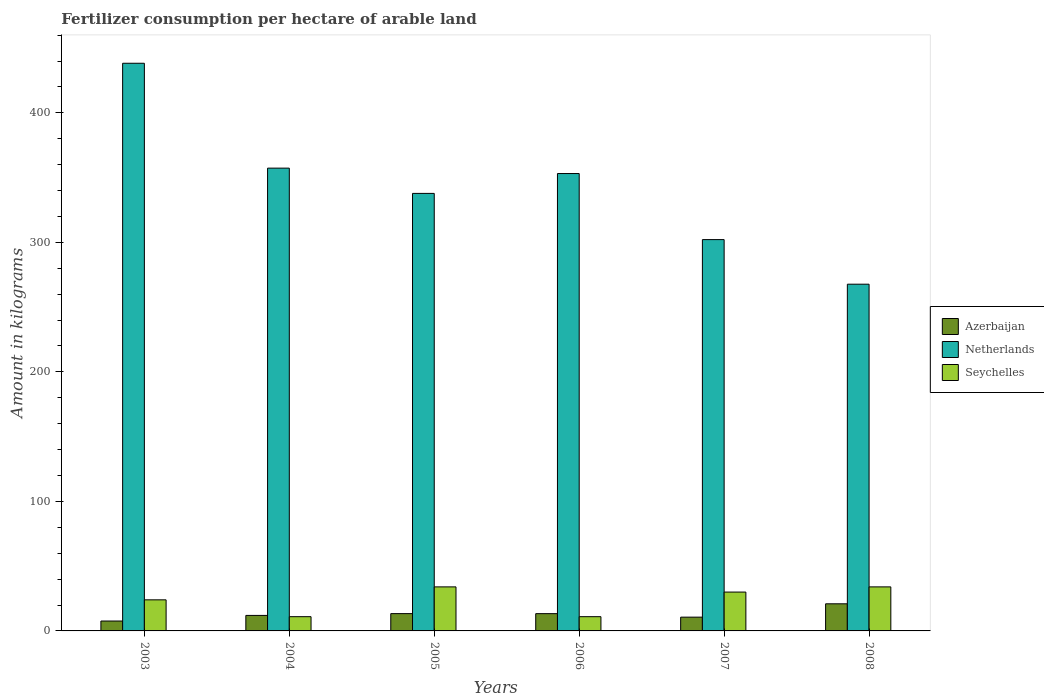How many groups of bars are there?
Offer a terse response. 6. Are the number of bars per tick equal to the number of legend labels?
Ensure brevity in your answer.  Yes. How many bars are there on the 3rd tick from the left?
Provide a succinct answer. 3. How many bars are there on the 1st tick from the right?
Give a very brief answer. 3. What is the label of the 5th group of bars from the left?
Give a very brief answer. 2007. In how many cases, is the number of bars for a given year not equal to the number of legend labels?
Offer a very short reply. 0. What is the amount of fertilizer consumption in Azerbaijan in 2007?
Make the answer very short. 10.64. Across all years, what is the maximum amount of fertilizer consumption in Azerbaijan?
Give a very brief answer. 20.94. Across all years, what is the minimum amount of fertilizer consumption in Seychelles?
Keep it short and to the point. 11. In which year was the amount of fertilizer consumption in Netherlands minimum?
Keep it short and to the point. 2008. What is the total amount of fertilizer consumption in Seychelles in the graph?
Keep it short and to the point. 144. What is the difference between the amount of fertilizer consumption in Netherlands in 2003 and that in 2006?
Your answer should be compact. 85.15. What is the difference between the amount of fertilizer consumption in Azerbaijan in 2003 and the amount of fertilizer consumption in Netherlands in 2005?
Keep it short and to the point. -330.16. In the year 2006, what is the difference between the amount of fertilizer consumption in Netherlands and amount of fertilizer consumption in Seychelles?
Provide a short and direct response. 342.15. What is the ratio of the amount of fertilizer consumption in Azerbaijan in 2005 to that in 2006?
Give a very brief answer. 1. Is the amount of fertilizer consumption in Seychelles in 2004 less than that in 2007?
Give a very brief answer. Yes. Is the difference between the amount of fertilizer consumption in Netherlands in 2003 and 2005 greater than the difference between the amount of fertilizer consumption in Seychelles in 2003 and 2005?
Your response must be concise. Yes. What is the difference between the highest and the second highest amount of fertilizer consumption in Seychelles?
Your response must be concise. 0. What is the difference between the highest and the lowest amount of fertilizer consumption in Seychelles?
Provide a short and direct response. 23. What does the 1st bar from the left in 2004 represents?
Keep it short and to the point. Azerbaijan. What does the 1st bar from the right in 2003 represents?
Make the answer very short. Seychelles. Is it the case that in every year, the sum of the amount of fertilizer consumption in Netherlands and amount of fertilizer consumption in Seychelles is greater than the amount of fertilizer consumption in Azerbaijan?
Keep it short and to the point. Yes. How many bars are there?
Make the answer very short. 18. What is the difference between two consecutive major ticks on the Y-axis?
Offer a very short reply. 100. Does the graph contain any zero values?
Offer a terse response. No. Does the graph contain grids?
Offer a very short reply. No. Where does the legend appear in the graph?
Make the answer very short. Center right. How many legend labels are there?
Make the answer very short. 3. How are the legend labels stacked?
Keep it short and to the point. Vertical. What is the title of the graph?
Offer a very short reply. Fertilizer consumption per hectare of arable land. What is the label or title of the Y-axis?
Offer a terse response. Amount in kilograms. What is the Amount in kilograms of Azerbaijan in 2003?
Give a very brief answer. 7.64. What is the Amount in kilograms of Netherlands in 2003?
Keep it short and to the point. 438.29. What is the Amount in kilograms in Seychelles in 2003?
Give a very brief answer. 24. What is the Amount in kilograms in Azerbaijan in 2004?
Give a very brief answer. 11.97. What is the Amount in kilograms of Netherlands in 2004?
Offer a terse response. 357.31. What is the Amount in kilograms in Azerbaijan in 2005?
Offer a terse response. 13.36. What is the Amount in kilograms in Netherlands in 2005?
Your answer should be compact. 337.81. What is the Amount in kilograms in Azerbaijan in 2006?
Give a very brief answer. 13.34. What is the Amount in kilograms in Netherlands in 2006?
Keep it short and to the point. 353.15. What is the Amount in kilograms of Azerbaijan in 2007?
Ensure brevity in your answer.  10.64. What is the Amount in kilograms in Netherlands in 2007?
Offer a very short reply. 302.14. What is the Amount in kilograms in Azerbaijan in 2008?
Provide a short and direct response. 20.94. What is the Amount in kilograms of Netherlands in 2008?
Your response must be concise. 267.71. Across all years, what is the maximum Amount in kilograms of Azerbaijan?
Make the answer very short. 20.94. Across all years, what is the maximum Amount in kilograms in Netherlands?
Your answer should be very brief. 438.29. Across all years, what is the maximum Amount in kilograms of Seychelles?
Make the answer very short. 34. Across all years, what is the minimum Amount in kilograms in Azerbaijan?
Provide a short and direct response. 7.64. Across all years, what is the minimum Amount in kilograms in Netherlands?
Provide a succinct answer. 267.71. What is the total Amount in kilograms of Azerbaijan in the graph?
Your answer should be very brief. 77.89. What is the total Amount in kilograms of Netherlands in the graph?
Your response must be concise. 2056.41. What is the total Amount in kilograms in Seychelles in the graph?
Your response must be concise. 144. What is the difference between the Amount in kilograms of Azerbaijan in 2003 and that in 2004?
Provide a short and direct response. -4.33. What is the difference between the Amount in kilograms of Netherlands in 2003 and that in 2004?
Offer a very short reply. 80.98. What is the difference between the Amount in kilograms of Azerbaijan in 2003 and that in 2005?
Provide a short and direct response. -5.72. What is the difference between the Amount in kilograms in Netherlands in 2003 and that in 2005?
Give a very brief answer. 100.48. What is the difference between the Amount in kilograms of Seychelles in 2003 and that in 2005?
Your response must be concise. -10. What is the difference between the Amount in kilograms of Azerbaijan in 2003 and that in 2006?
Provide a short and direct response. -5.7. What is the difference between the Amount in kilograms of Netherlands in 2003 and that in 2006?
Make the answer very short. 85.14. What is the difference between the Amount in kilograms of Seychelles in 2003 and that in 2006?
Your answer should be very brief. 13. What is the difference between the Amount in kilograms in Azerbaijan in 2003 and that in 2007?
Offer a terse response. -3. What is the difference between the Amount in kilograms of Netherlands in 2003 and that in 2007?
Keep it short and to the point. 136.15. What is the difference between the Amount in kilograms in Azerbaijan in 2003 and that in 2008?
Ensure brevity in your answer.  -13.3. What is the difference between the Amount in kilograms in Netherlands in 2003 and that in 2008?
Provide a succinct answer. 170.58. What is the difference between the Amount in kilograms of Azerbaijan in 2004 and that in 2005?
Ensure brevity in your answer.  -1.39. What is the difference between the Amount in kilograms in Netherlands in 2004 and that in 2005?
Your answer should be compact. 19.51. What is the difference between the Amount in kilograms of Seychelles in 2004 and that in 2005?
Offer a very short reply. -23. What is the difference between the Amount in kilograms in Azerbaijan in 2004 and that in 2006?
Offer a terse response. -1.36. What is the difference between the Amount in kilograms of Netherlands in 2004 and that in 2006?
Provide a short and direct response. 4.17. What is the difference between the Amount in kilograms of Seychelles in 2004 and that in 2006?
Your response must be concise. 0. What is the difference between the Amount in kilograms in Azerbaijan in 2004 and that in 2007?
Your answer should be compact. 1.34. What is the difference between the Amount in kilograms of Netherlands in 2004 and that in 2007?
Give a very brief answer. 55.17. What is the difference between the Amount in kilograms in Seychelles in 2004 and that in 2007?
Ensure brevity in your answer.  -19. What is the difference between the Amount in kilograms of Azerbaijan in 2004 and that in 2008?
Keep it short and to the point. -8.96. What is the difference between the Amount in kilograms of Netherlands in 2004 and that in 2008?
Your answer should be very brief. 89.6. What is the difference between the Amount in kilograms in Seychelles in 2004 and that in 2008?
Ensure brevity in your answer.  -23. What is the difference between the Amount in kilograms in Azerbaijan in 2005 and that in 2006?
Your answer should be very brief. 0.02. What is the difference between the Amount in kilograms in Netherlands in 2005 and that in 2006?
Your answer should be compact. -15.34. What is the difference between the Amount in kilograms of Seychelles in 2005 and that in 2006?
Provide a short and direct response. 23. What is the difference between the Amount in kilograms in Azerbaijan in 2005 and that in 2007?
Keep it short and to the point. 2.72. What is the difference between the Amount in kilograms of Netherlands in 2005 and that in 2007?
Your answer should be compact. 35.67. What is the difference between the Amount in kilograms of Azerbaijan in 2005 and that in 2008?
Your answer should be very brief. -7.58. What is the difference between the Amount in kilograms of Netherlands in 2005 and that in 2008?
Provide a succinct answer. 70.1. What is the difference between the Amount in kilograms in Azerbaijan in 2006 and that in 2007?
Provide a short and direct response. 2.7. What is the difference between the Amount in kilograms of Netherlands in 2006 and that in 2007?
Provide a short and direct response. 51.01. What is the difference between the Amount in kilograms of Azerbaijan in 2006 and that in 2008?
Your response must be concise. -7.6. What is the difference between the Amount in kilograms of Netherlands in 2006 and that in 2008?
Keep it short and to the point. 85.44. What is the difference between the Amount in kilograms of Seychelles in 2006 and that in 2008?
Make the answer very short. -23. What is the difference between the Amount in kilograms in Azerbaijan in 2007 and that in 2008?
Offer a terse response. -10.3. What is the difference between the Amount in kilograms of Netherlands in 2007 and that in 2008?
Offer a very short reply. 34.43. What is the difference between the Amount in kilograms in Azerbaijan in 2003 and the Amount in kilograms in Netherlands in 2004?
Your response must be concise. -349.67. What is the difference between the Amount in kilograms in Azerbaijan in 2003 and the Amount in kilograms in Seychelles in 2004?
Provide a short and direct response. -3.36. What is the difference between the Amount in kilograms in Netherlands in 2003 and the Amount in kilograms in Seychelles in 2004?
Your answer should be very brief. 427.29. What is the difference between the Amount in kilograms of Azerbaijan in 2003 and the Amount in kilograms of Netherlands in 2005?
Your answer should be very brief. -330.16. What is the difference between the Amount in kilograms in Azerbaijan in 2003 and the Amount in kilograms in Seychelles in 2005?
Your response must be concise. -26.36. What is the difference between the Amount in kilograms in Netherlands in 2003 and the Amount in kilograms in Seychelles in 2005?
Keep it short and to the point. 404.29. What is the difference between the Amount in kilograms in Azerbaijan in 2003 and the Amount in kilograms in Netherlands in 2006?
Keep it short and to the point. -345.5. What is the difference between the Amount in kilograms in Azerbaijan in 2003 and the Amount in kilograms in Seychelles in 2006?
Offer a very short reply. -3.36. What is the difference between the Amount in kilograms in Netherlands in 2003 and the Amount in kilograms in Seychelles in 2006?
Ensure brevity in your answer.  427.29. What is the difference between the Amount in kilograms of Azerbaijan in 2003 and the Amount in kilograms of Netherlands in 2007?
Ensure brevity in your answer.  -294.5. What is the difference between the Amount in kilograms of Azerbaijan in 2003 and the Amount in kilograms of Seychelles in 2007?
Your response must be concise. -22.36. What is the difference between the Amount in kilograms in Netherlands in 2003 and the Amount in kilograms in Seychelles in 2007?
Give a very brief answer. 408.29. What is the difference between the Amount in kilograms of Azerbaijan in 2003 and the Amount in kilograms of Netherlands in 2008?
Offer a terse response. -260.07. What is the difference between the Amount in kilograms of Azerbaijan in 2003 and the Amount in kilograms of Seychelles in 2008?
Make the answer very short. -26.36. What is the difference between the Amount in kilograms in Netherlands in 2003 and the Amount in kilograms in Seychelles in 2008?
Provide a short and direct response. 404.29. What is the difference between the Amount in kilograms in Azerbaijan in 2004 and the Amount in kilograms in Netherlands in 2005?
Keep it short and to the point. -325.83. What is the difference between the Amount in kilograms in Azerbaijan in 2004 and the Amount in kilograms in Seychelles in 2005?
Ensure brevity in your answer.  -22.03. What is the difference between the Amount in kilograms of Netherlands in 2004 and the Amount in kilograms of Seychelles in 2005?
Your answer should be very brief. 323.31. What is the difference between the Amount in kilograms of Azerbaijan in 2004 and the Amount in kilograms of Netherlands in 2006?
Provide a succinct answer. -341.17. What is the difference between the Amount in kilograms in Azerbaijan in 2004 and the Amount in kilograms in Seychelles in 2006?
Ensure brevity in your answer.  0.97. What is the difference between the Amount in kilograms of Netherlands in 2004 and the Amount in kilograms of Seychelles in 2006?
Your answer should be very brief. 346.31. What is the difference between the Amount in kilograms in Azerbaijan in 2004 and the Amount in kilograms in Netherlands in 2007?
Offer a very short reply. -290.16. What is the difference between the Amount in kilograms in Azerbaijan in 2004 and the Amount in kilograms in Seychelles in 2007?
Keep it short and to the point. -18.03. What is the difference between the Amount in kilograms of Netherlands in 2004 and the Amount in kilograms of Seychelles in 2007?
Give a very brief answer. 327.31. What is the difference between the Amount in kilograms of Azerbaijan in 2004 and the Amount in kilograms of Netherlands in 2008?
Keep it short and to the point. -255.73. What is the difference between the Amount in kilograms of Azerbaijan in 2004 and the Amount in kilograms of Seychelles in 2008?
Your answer should be very brief. -22.03. What is the difference between the Amount in kilograms in Netherlands in 2004 and the Amount in kilograms in Seychelles in 2008?
Provide a succinct answer. 323.31. What is the difference between the Amount in kilograms of Azerbaijan in 2005 and the Amount in kilograms of Netherlands in 2006?
Keep it short and to the point. -339.79. What is the difference between the Amount in kilograms in Azerbaijan in 2005 and the Amount in kilograms in Seychelles in 2006?
Provide a succinct answer. 2.36. What is the difference between the Amount in kilograms in Netherlands in 2005 and the Amount in kilograms in Seychelles in 2006?
Offer a very short reply. 326.81. What is the difference between the Amount in kilograms in Azerbaijan in 2005 and the Amount in kilograms in Netherlands in 2007?
Your answer should be very brief. -288.78. What is the difference between the Amount in kilograms of Azerbaijan in 2005 and the Amount in kilograms of Seychelles in 2007?
Provide a succinct answer. -16.64. What is the difference between the Amount in kilograms of Netherlands in 2005 and the Amount in kilograms of Seychelles in 2007?
Make the answer very short. 307.81. What is the difference between the Amount in kilograms in Azerbaijan in 2005 and the Amount in kilograms in Netherlands in 2008?
Your answer should be very brief. -254.35. What is the difference between the Amount in kilograms of Azerbaijan in 2005 and the Amount in kilograms of Seychelles in 2008?
Offer a very short reply. -20.64. What is the difference between the Amount in kilograms in Netherlands in 2005 and the Amount in kilograms in Seychelles in 2008?
Ensure brevity in your answer.  303.81. What is the difference between the Amount in kilograms in Azerbaijan in 2006 and the Amount in kilograms in Netherlands in 2007?
Ensure brevity in your answer.  -288.8. What is the difference between the Amount in kilograms of Azerbaijan in 2006 and the Amount in kilograms of Seychelles in 2007?
Offer a terse response. -16.66. What is the difference between the Amount in kilograms of Netherlands in 2006 and the Amount in kilograms of Seychelles in 2007?
Your response must be concise. 323.15. What is the difference between the Amount in kilograms of Azerbaijan in 2006 and the Amount in kilograms of Netherlands in 2008?
Your response must be concise. -254.37. What is the difference between the Amount in kilograms of Azerbaijan in 2006 and the Amount in kilograms of Seychelles in 2008?
Give a very brief answer. -20.66. What is the difference between the Amount in kilograms of Netherlands in 2006 and the Amount in kilograms of Seychelles in 2008?
Your answer should be very brief. 319.15. What is the difference between the Amount in kilograms in Azerbaijan in 2007 and the Amount in kilograms in Netherlands in 2008?
Ensure brevity in your answer.  -257.07. What is the difference between the Amount in kilograms of Azerbaijan in 2007 and the Amount in kilograms of Seychelles in 2008?
Offer a terse response. -23.36. What is the difference between the Amount in kilograms of Netherlands in 2007 and the Amount in kilograms of Seychelles in 2008?
Make the answer very short. 268.14. What is the average Amount in kilograms of Azerbaijan per year?
Your response must be concise. 12.98. What is the average Amount in kilograms in Netherlands per year?
Provide a succinct answer. 342.73. In the year 2003, what is the difference between the Amount in kilograms of Azerbaijan and Amount in kilograms of Netherlands?
Give a very brief answer. -430.65. In the year 2003, what is the difference between the Amount in kilograms in Azerbaijan and Amount in kilograms in Seychelles?
Your answer should be very brief. -16.36. In the year 2003, what is the difference between the Amount in kilograms of Netherlands and Amount in kilograms of Seychelles?
Keep it short and to the point. 414.29. In the year 2004, what is the difference between the Amount in kilograms in Azerbaijan and Amount in kilograms in Netherlands?
Your answer should be very brief. -345.34. In the year 2004, what is the difference between the Amount in kilograms of Azerbaijan and Amount in kilograms of Seychelles?
Give a very brief answer. 0.97. In the year 2004, what is the difference between the Amount in kilograms of Netherlands and Amount in kilograms of Seychelles?
Ensure brevity in your answer.  346.31. In the year 2005, what is the difference between the Amount in kilograms in Azerbaijan and Amount in kilograms in Netherlands?
Give a very brief answer. -324.45. In the year 2005, what is the difference between the Amount in kilograms in Azerbaijan and Amount in kilograms in Seychelles?
Give a very brief answer. -20.64. In the year 2005, what is the difference between the Amount in kilograms of Netherlands and Amount in kilograms of Seychelles?
Ensure brevity in your answer.  303.81. In the year 2006, what is the difference between the Amount in kilograms in Azerbaijan and Amount in kilograms in Netherlands?
Your answer should be very brief. -339.81. In the year 2006, what is the difference between the Amount in kilograms of Azerbaijan and Amount in kilograms of Seychelles?
Make the answer very short. 2.34. In the year 2006, what is the difference between the Amount in kilograms in Netherlands and Amount in kilograms in Seychelles?
Provide a short and direct response. 342.15. In the year 2007, what is the difference between the Amount in kilograms of Azerbaijan and Amount in kilograms of Netherlands?
Provide a succinct answer. -291.5. In the year 2007, what is the difference between the Amount in kilograms in Azerbaijan and Amount in kilograms in Seychelles?
Provide a succinct answer. -19.36. In the year 2007, what is the difference between the Amount in kilograms of Netherlands and Amount in kilograms of Seychelles?
Your answer should be very brief. 272.14. In the year 2008, what is the difference between the Amount in kilograms of Azerbaijan and Amount in kilograms of Netherlands?
Your answer should be very brief. -246.77. In the year 2008, what is the difference between the Amount in kilograms of Azerbaijan and Amount in kilograms of Seychelles?
Give a very brief answer. -13.06. In the year 2008, what is the difference between the Amount in kilograms in Netherlands and Amount in kilograms in Seychelles?
Offer a terse response. 233.71. What is the ratio of the Amount in kilograms in Azerbaijan in 2003 to that in 2004?
Ensure brevity in your answer.  0.64. What is the ratio of the Amount in kilograms in Netherlands in 2003 to that in 2004?
Offer a very short reply. 1.23. What is the ratio of the Amount in kilograms in Seychelles in 2003 to that in 2004?
Your answer should be compact. 2.18. What is the ratio of the Amount in kilograms of Azerbaijan in 2003 to that in 2005?
Ensure brevity in your answer.  0.57. What is the ratio of the Amount in kilograms of Netherlands in 2003 to that in 2005?
Your response must be concise. 1.3. What is the ratio of the Amount in kilograms of Seychelles in 2003 to that in 2005?
Make the answer very short. 0.71. What is the ratio of the Amount in kilograms of Azerbaijan in 2003 to that in 2006?
Give a very brief answer. 0.57. What is the ratio of the Amount in kilograms of Netherlands in 2003 to that in 2006?
Your response must be concise. 1.24. What is the ratio of the Amount in kilograms of Seychelles in 2003 to that in 2006?
Your response must be concise. 2.18. What is the ratio of the Amount in kilograms in Azerbaijan in 2003 to that in 2007?
Offer a very short reply. 0.72. What is the ratio of the Amount in kilograms of Netherlands in 2003 to that in 2007?
Give a very brief answer. 1.45. What is the ratio of the Amount in kilograms of Seychelles in 2003 to that in 2007?
Your response must be concise. 0.8. What is the ratio of the Amount in kilograms of Azerbaijan in 2003 to that in 2008?
Your answer should be compact. 0.36. What is the ratio of the Amount in kilograms of Netherlands in 2003 to that in 2008?
Provide a short and direct response. 1.64. What is the ratio of the Amount in kilograms of Seychelles in 2003 to that in 2008?
Your response must be concise. 0.71. What is the ratio of the Amount in kilograms in Azerbaijan in 2004 to that in 2005?
Make the answer very short. 0.9. What is the ratio of the Amount in kilograms of Netherlands in 2004 to that in 2005?
Keep it short and to the point. 1.06. What is the ratio of the Amount in kilograms of Seychelles in 2004 to that in 2005?
Your answer should be very brief. 0.32. What is the ratio of the Amount in kilograms in Azerbaijan in 2004 to that in 2006?
Offer a terse response. 0.9. What is the ratio of the Amount in kilograms in Netherlands in 2004 to that in 2006?
Provide a succinct answer. 1.01. What is the ratio of the Amount in kilograms of Seychelles in 2004 to that in 2006?
Your answer should be compact. 1. What is the ratio of the Amount in kilograms in Azerbaijan in 2004 to that in 2007?
Provide a succinct answer. 1.13. What is the ratio of the Amount in kilograms in Netherlands in 2004 to that in 2007?
Offer a terse response. 1.18. What is the ratio of the Amount in kilograms in Seychelles in 2004 to that in 2007?
Give a very brief answer. 0.37. What is the ratio of the Amount in kilograms in Azerbaijan in 2004 to that in 2008?
Offer a terse response. 0.57. What is the ratio of the Amount in kilograms of Netherlands in 2004 to that in 2008?
Your response must be concise. 1.33. What is the ratio of the Amount in kilograms in Seychelles in 2004 to that in 2008?
Make the answer very short. 0.32. What is the ratio of the Amount in kilograms in Netherlands in 2005 to that in 2006?
Provide a succinct answer. 0.96. What is the ratio of the Amount in kilograms in Seychelles in 2005 to that in 2006?
Offer a terse response. 3.09. What is the ratio of the Amount in kilograms of Azerbaijan in 2005 to that in 2007?
Your answer should be very brief. 1.26. What is the ratio of the Amount in kilograms in Netherlands in 2005 to that in 2007?
Your answer should be compact. 1.12. What is the ratio of the Amount in kilograms of Seychelles in 2005 to that in 2007?
Make the answer very short. 1.13. What is the ratio of the Amount in kilograms of Azerbaijan in 2005 to that in 2008?
Your response must be concise. 0.64. What is the ratio of the Amount in kilograms in Netherlands in 2005 to that in 2008?
Make the answer very short. 1.26. What is the ratio of the Amount in kilograms in Seychelles in 2005 to that in 2008?
Your answer should be compact. 1. What is the ratio of the Amount in kilograms of Azerbaijan in 2006 to that in 2007?
Ensure brevity in your answer.  1.25. What is the ratio of the Amount in kilograms in Netherlands in 2006 to that in 2007?
Provide a succinct answer. 1.17. What is the ratio of the Amount in kilograms in Seychelles in 2006 to that in 2007?
Make the answer very short. 0.37. What is the ratio of the Amount in kilograms of Azerbaijan in 2006 to that in 2008?
Your answer should be compact. 0.64. What is the ratio of the Amount in kilograms of Netherlands in 2006 to that in 2008?
Provide a short and direct response. 1.32. What is the ratio of the Amount in kilograms of Seychelles in 2006 to that in 2008?
Provide a succinct answer. 0.32. What is the ratio of the Amount in kilograms of Azerbaijan in 2007 to that in 2008?
Make the answer very short. 0.51. What is the ratio of the Amount in kilograms in Netherlands in 2007 to that in 2008?
Your answer should be very brief. 1.13. What is the ratio of the Amount in kilograms of Seychelles in 2007 to that in 2008?
Give a very brief answer. 0.88. What is the difference between the highest and the second highest Amount in kilograms of Azerbaijan?
Offer a terse response. 7.58. What is the difference between the highest and the second highest Amount in kilograms in Netherlands?
Your answer should be compact. 80.98. What is the difference between the highest and the lowest Amount in kilograms of Azerbaijan?
Offer a very short reply. 13.3. What is the difference between the highest and the lowest Amount in kilograms of Netherlands?
Make the answer very short. 170.58. 